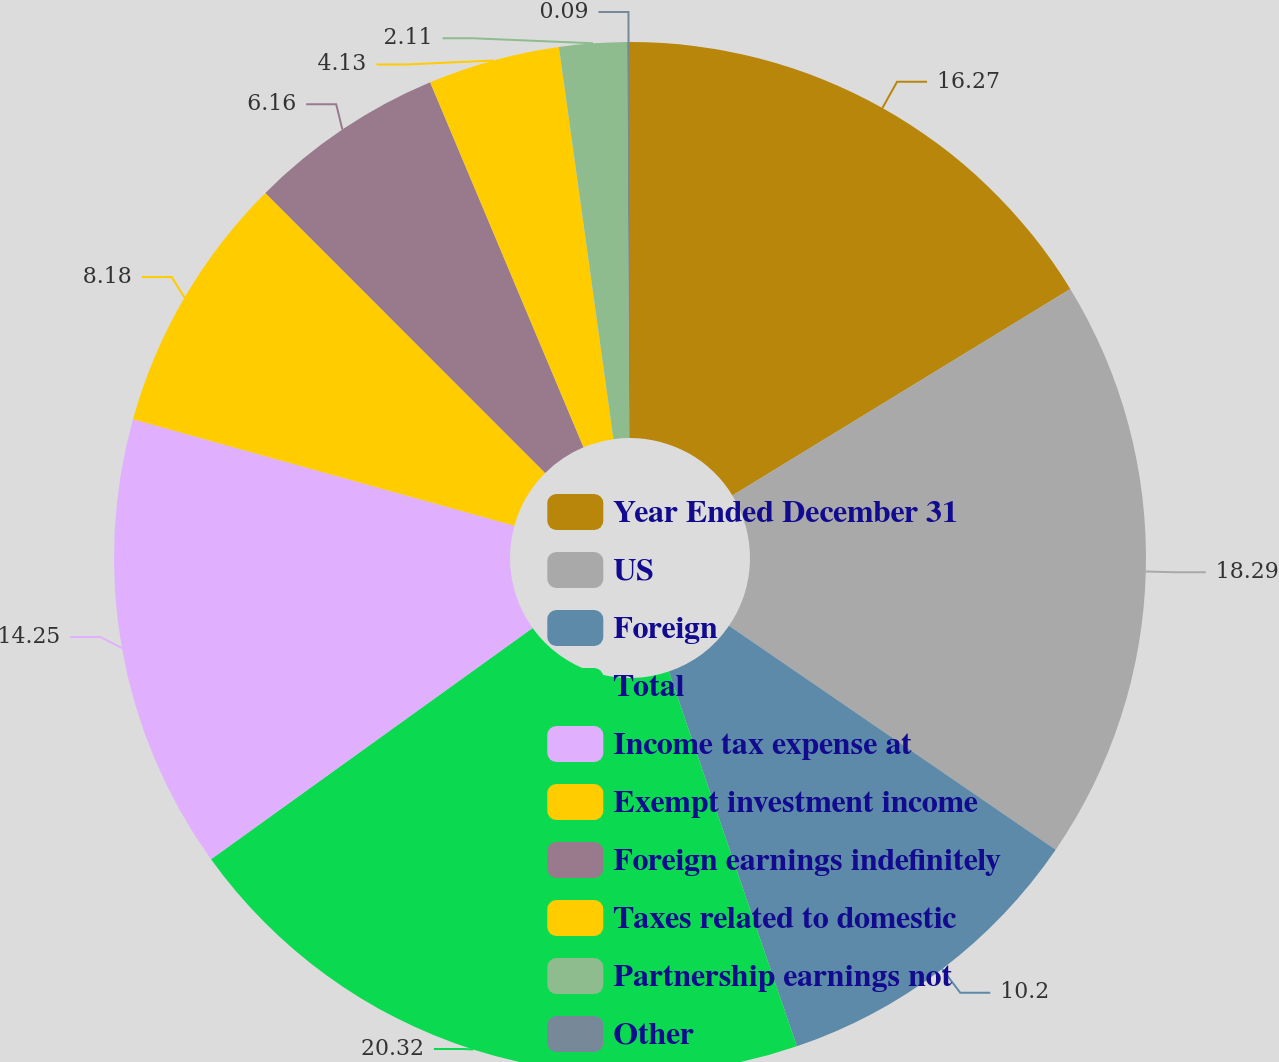Convert chart. <chart><loc_0><loc_0><loc_500><loc_500><pie_chart><fcel>Year Ended December 31<fcel>US<fcel>Foreign<fcel>Total<fcel>Income tax expense at<fcel>Exempt investment income<fcel>Foreign earnings indefinitely<fcel>Taxes related to domestic<fcel>Partnership earnings not<fcel>Other<nl><fcel>16.27%<fcel>18.29%<fcel>10.2%<fcel>20.32%<fcel>14.25%<fcel>8.18%<fcel>6.16%<fcel>4.13%<fcel>2.11%<fcel>0.09%<nl></chart> 